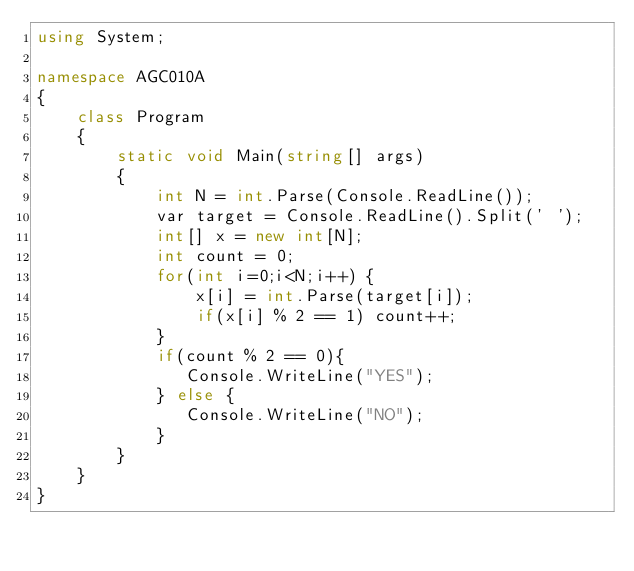Convert code to text. <code><loc_0><loc_0><loc_500><loc_500><_C#_>using System;

namespace AGC010A
{
    class Program
    {
        static void Main(string[] args)
        {
            int N = int.Parse(Console.ReadLine());
            var target = Console.ReadLine().Split(' ');
            int[] x = new int[N];
            int count = 0; 
            for(int i=0;i<N;i++) {
                x[i] = int.Parse(target[i]);
                if(x[i] % 2 == 1) count++;
            }
            if(count % 2 == 0){
               Console.WriteLine("YES");
            } else {
               Console.WriteLine("NO");
            }
        }
    }
}
</code> 